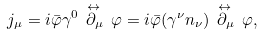Convert formula to latex. <formula><loc_0><loc_0><loc_500><loc_500>j _ { \mu } = i \bar { \varphi } \gamma ^ { 0 } \, \stackrel { \leftrightarrow \, } { \partial _ { \mu } } \, \varphi = i \bar { \varphi } ( \gamma ^ { \nu } n _ { \nu } ) \, \stackrel { \leftrightarrow \, } { \partial _ { \mu } } \, \varphi ,</formula> 